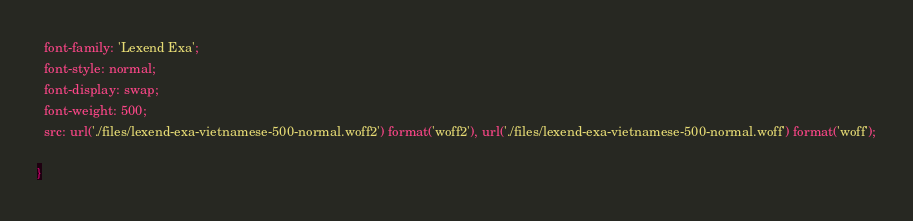Convert code to text. <code><loc_0><loc_0><loc_500><loc_500><_CSS_>  font-family: 'Lexend Exa';
  font-style: normal;
  font-display: swap;
  font-weight: 500;
  src: url('./files/lexend-exa-vietnamese-500-normal.woff2') format('woff2'), url('./files/lexend-exa-vietnamese-500-normal.woff') format('woff');
  
}
</code> 